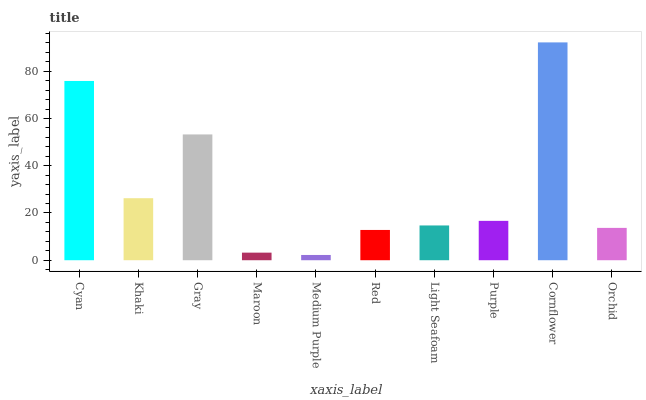Is Medium Purple the minimum?
Answer yes or no. Yes. Is Cornflower the maximum?
Answer yes or no. Yes. Is Khaki the minimum?
Answer yes or no. No. Is Khaki the maximum?
Answer yes or no. No. Is Cyan greater than Khaki?
Answer yes or no. Yes. Is Khaki less than Cyan?
Answer yes or no. Yes. Is Khaki greater than Cyan?
Answer yes or no. No. Is Cyan less than Khaki?
Answer yes or no. No. Is Purple the high median?
Answer yes or no. Yes. Is Light Seafoam the low median?
Answer yes or no. Yes. Is Red the high median?
Answer yes or no. No. Is Cyan the low median?
Answer yes or no. No. 